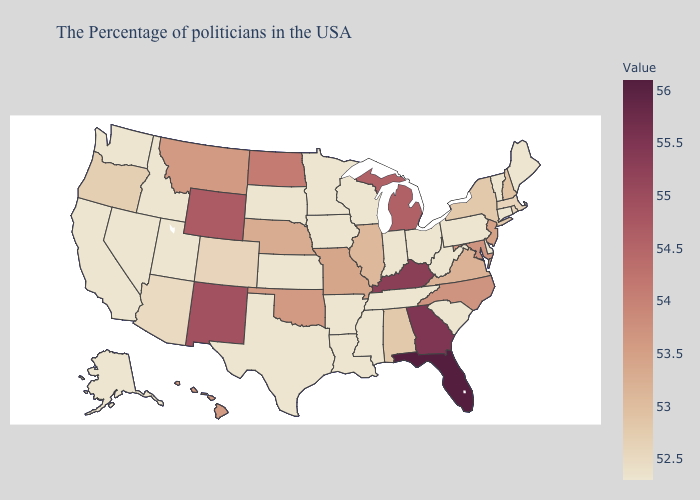Which states have the lowest value in the West?
Be succinct. Utah, Idaho, Nevada, California, Washington, Alaska. Does Alabama have the lowest value in the USA?
Short answer required. No. Which states hav the highest value in the MidWest?
Short answer required. Michigan. Among the states that border Arkansas , does Tennessee have the lowest value?
Give a very brief answer. Yes. 